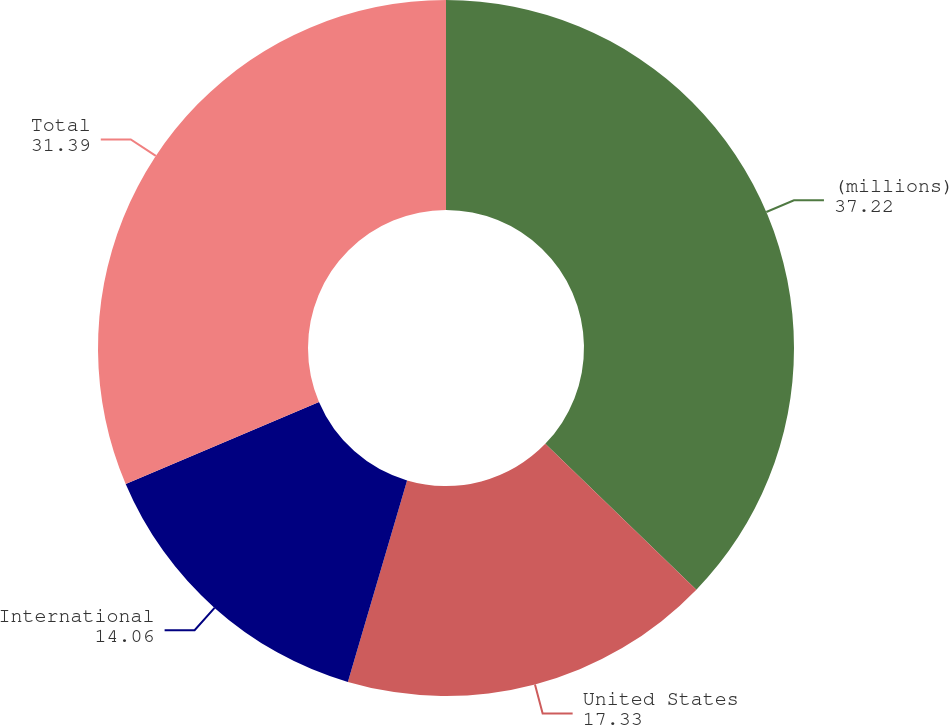<chart> <loc_0><loc_0><loc_500><loc_500><pie_chart><fcel>(millions)<fcel>United States<fcel>International<fcel>Total<nl><fcel>37.22%<fcel>17.33%<fcel>14.06%<fcel>31.39%<nl></chart> 